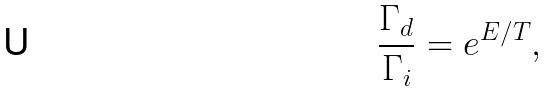<formula> <loc_0><loc_0><loc_500><loc_500>\frac { \Gamma _ { d } } { \Gamma _ { i } } = e ^ { E / T } ,</formula> 